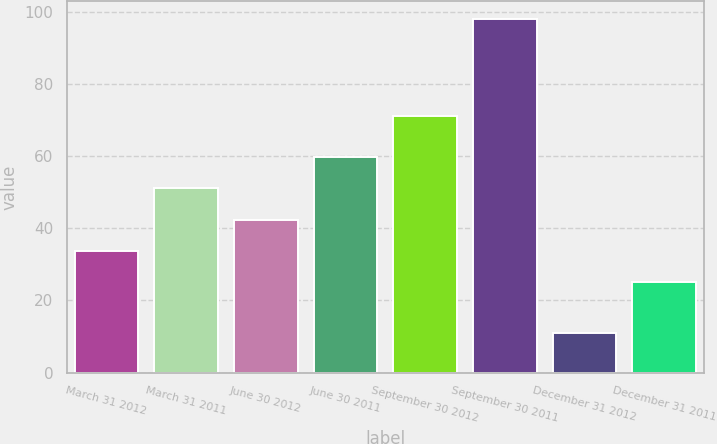Convert chart. <chart><loc_0><loc_0><loc_500><loc_500><bar_chart><fcel>March 31 2012<fcel>March 31 2011<fcel>June 30 2012<fcel>June 30 2011<fcel>September 30 2012<fcel>September 30 2011<fcel>December 31 2012<fcel>December 31 2011<nl><fcel>33.7<fcel>51.1<fcel>42.4<fcel>59.8<fcel>71<fcel>98<fcel>11<fcel>25<nl></chart> 